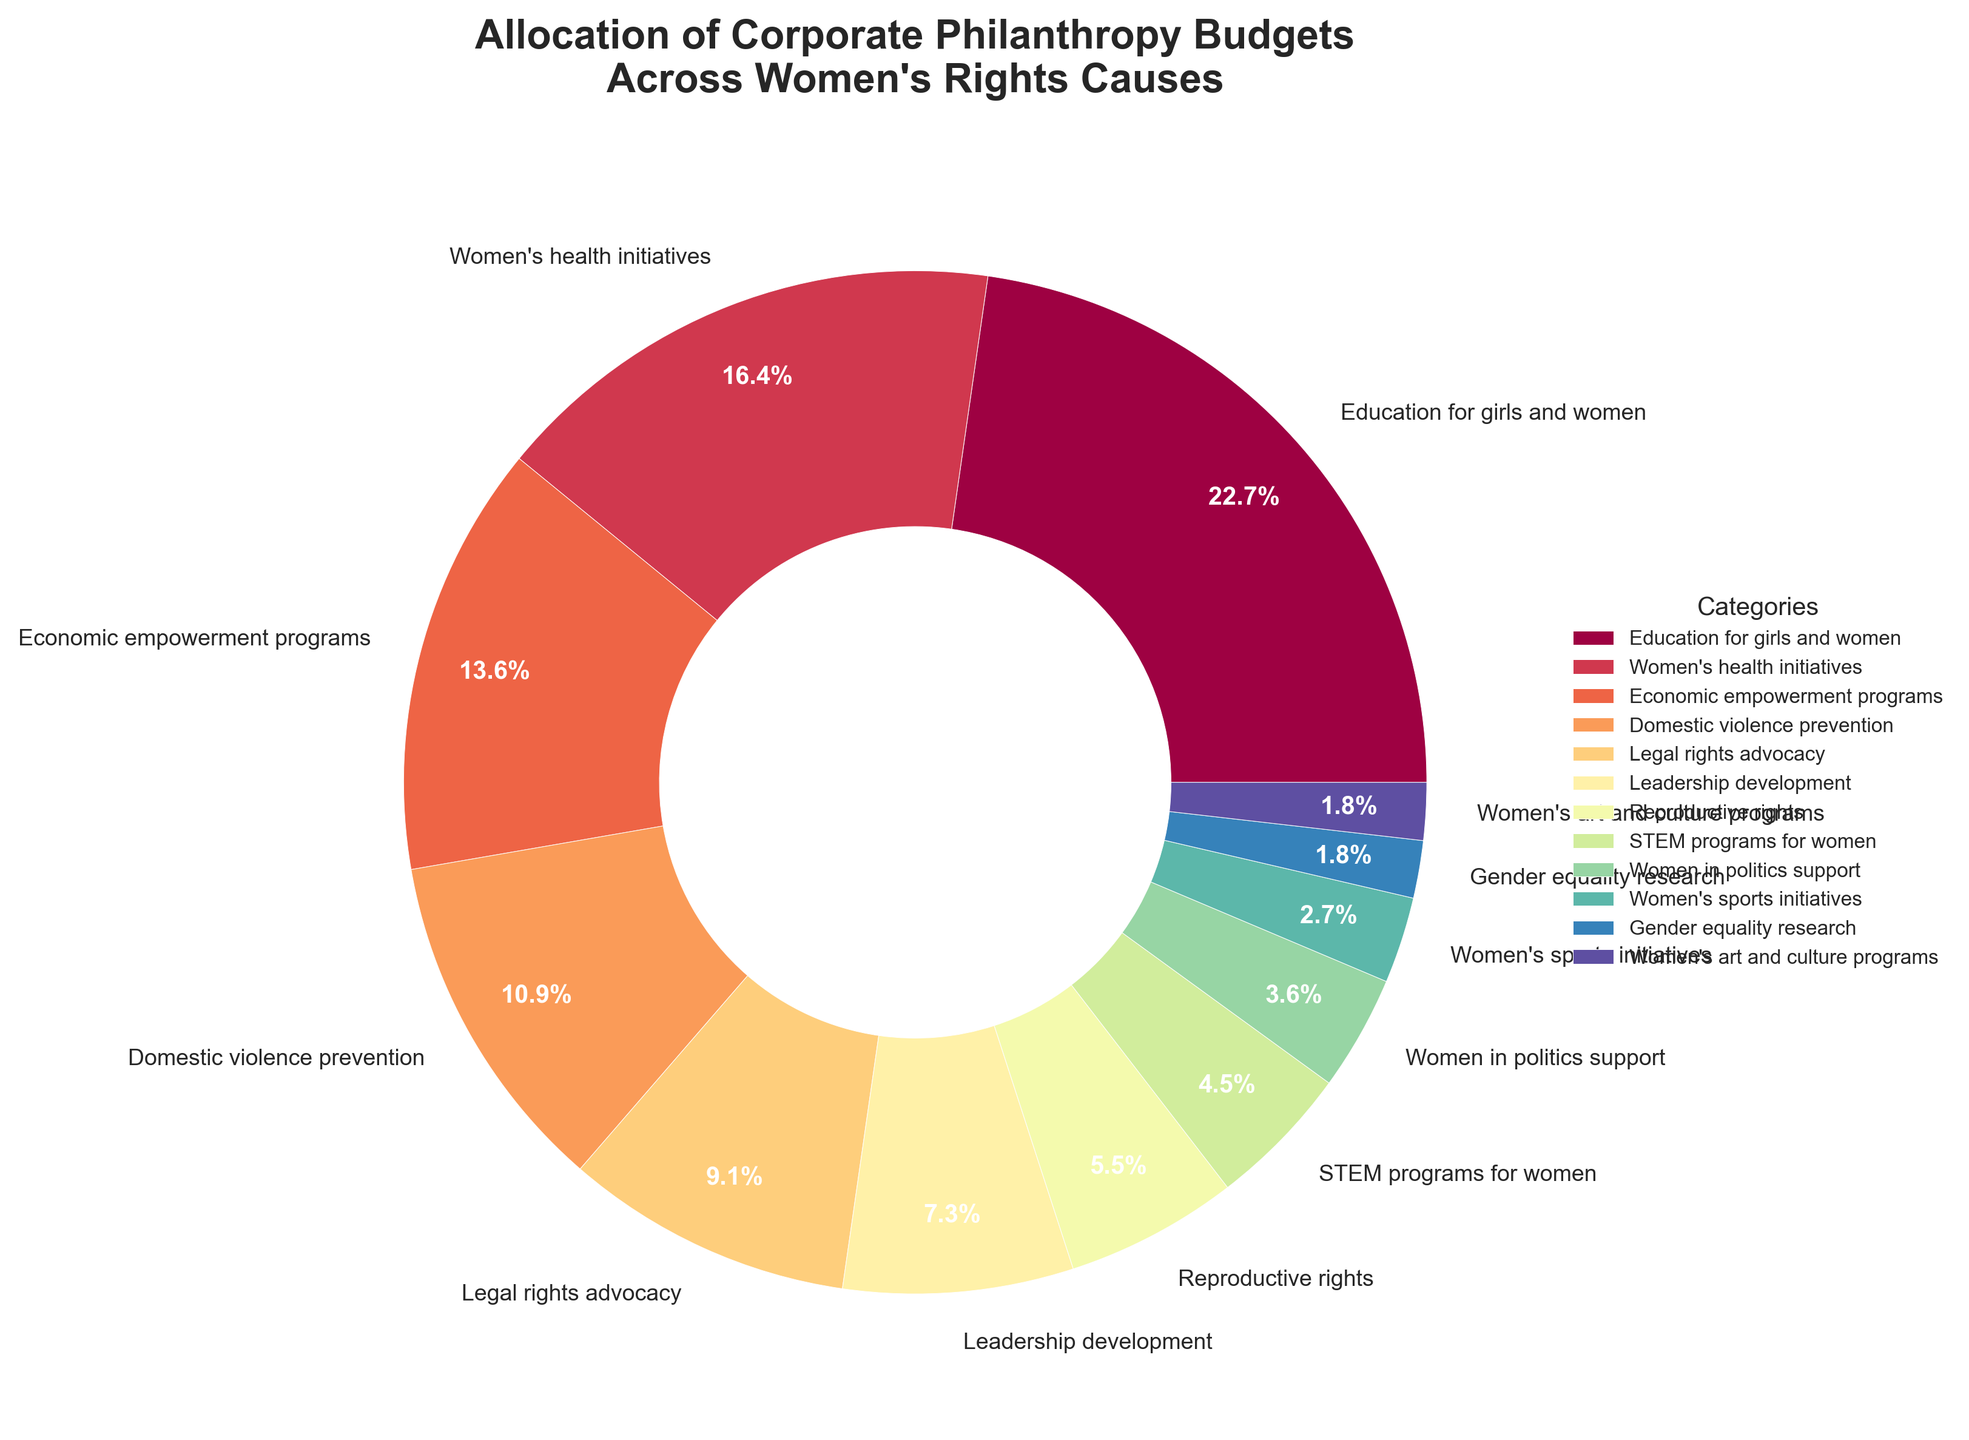What's the largest category in terms of budget allocation? To find the largest category, identify the segment with the highest percentage on the pie chart. From the chart, the "Education for girls and women" segment is the largest at 25%.
Answer: Education for girls and women Which category has a higher budget allocation: Women's health initiatives or Reproductive rights? Compare the percentages for Women's health initiatives (18%) and Reproductive rights (6%) on the pie chart. Women's health initiatives have a higher budget allocation.
Answer: Women's health initiatives What is the combined percentage for economic empowerment programs and leadership development? Sum the percentages for economic empowerment programs (15%) and leadership development (8%) from the pie chart. 15% + 8% = 23%.
Answer: 23% How much more budget is allocated to Domestic violence prevention compared to Women's sports initiatives? Calculate the difference between Domestic violence prevention (12%) and Women's sports initiatives (3%) as indicated on the pie chart: 12% - 3% = 9%.
Answer: 9% How many categories receive less than 5% of the budget? Identify and count all categories with percentages less than 5% from the pie chart: Women's sports initiatives (3%), Gender equality research (2%), Women's art and culture programs (2%), and Women in politics support (4%). There are 4 such categories.
Answer: 4 What are the three categories with the smallest budget allocation? Identify the three segments with the smallest percentages from the pie chart: Women in politics support (4%), Women's sports initiatives (3%), and both Gender equality research (2%) and Women's art and culture programs (2%).
Answer: Women in politics support, Women's sports initiatives, Gender equality research, and Women's art and culture programs Is the budget for Women's health initiatives more than twice the budget for STEM programs for women? Compare the percentages as shown on the pie chart: Women's health initiatives (18%) and STEM programs for women (5%). Check if 18% is more than twice of 5% (10%). Yes, it is.
Answer: Yes Which category has a lower budget allocation: Legal rights advocacy or Economic empowerment programs? Compare the percentages for Legal rights advocacy (10%) and Economic empowerment programs (15%) from the pie chart. Legal rights advocacy has a lower budget allocation.
Answer: Legal rights advocacy What is the average budget allocation for the categories with more than 10% each? Identify categories with more than 10%: Education for girls and women (25%), Women's health initiatives (18%), Economic empowerment programs (15%), and Domestic violence prevention (12%). Calculate the average: (25% + 18% + 15% + 12%) / 4 = 17.5%.
Answer: 17.5% What fraction of the total budget is dedicated to Women's health initiatives and Economic empowerment programs combined? Sum the percentages for Women's health initiatives (18%) and Economic empowerment programs (15%) from the pie chart to find the combined budget: 18% + 15% = 33%. Convert this into a fraction: 33/100.
Answer: 33/100 